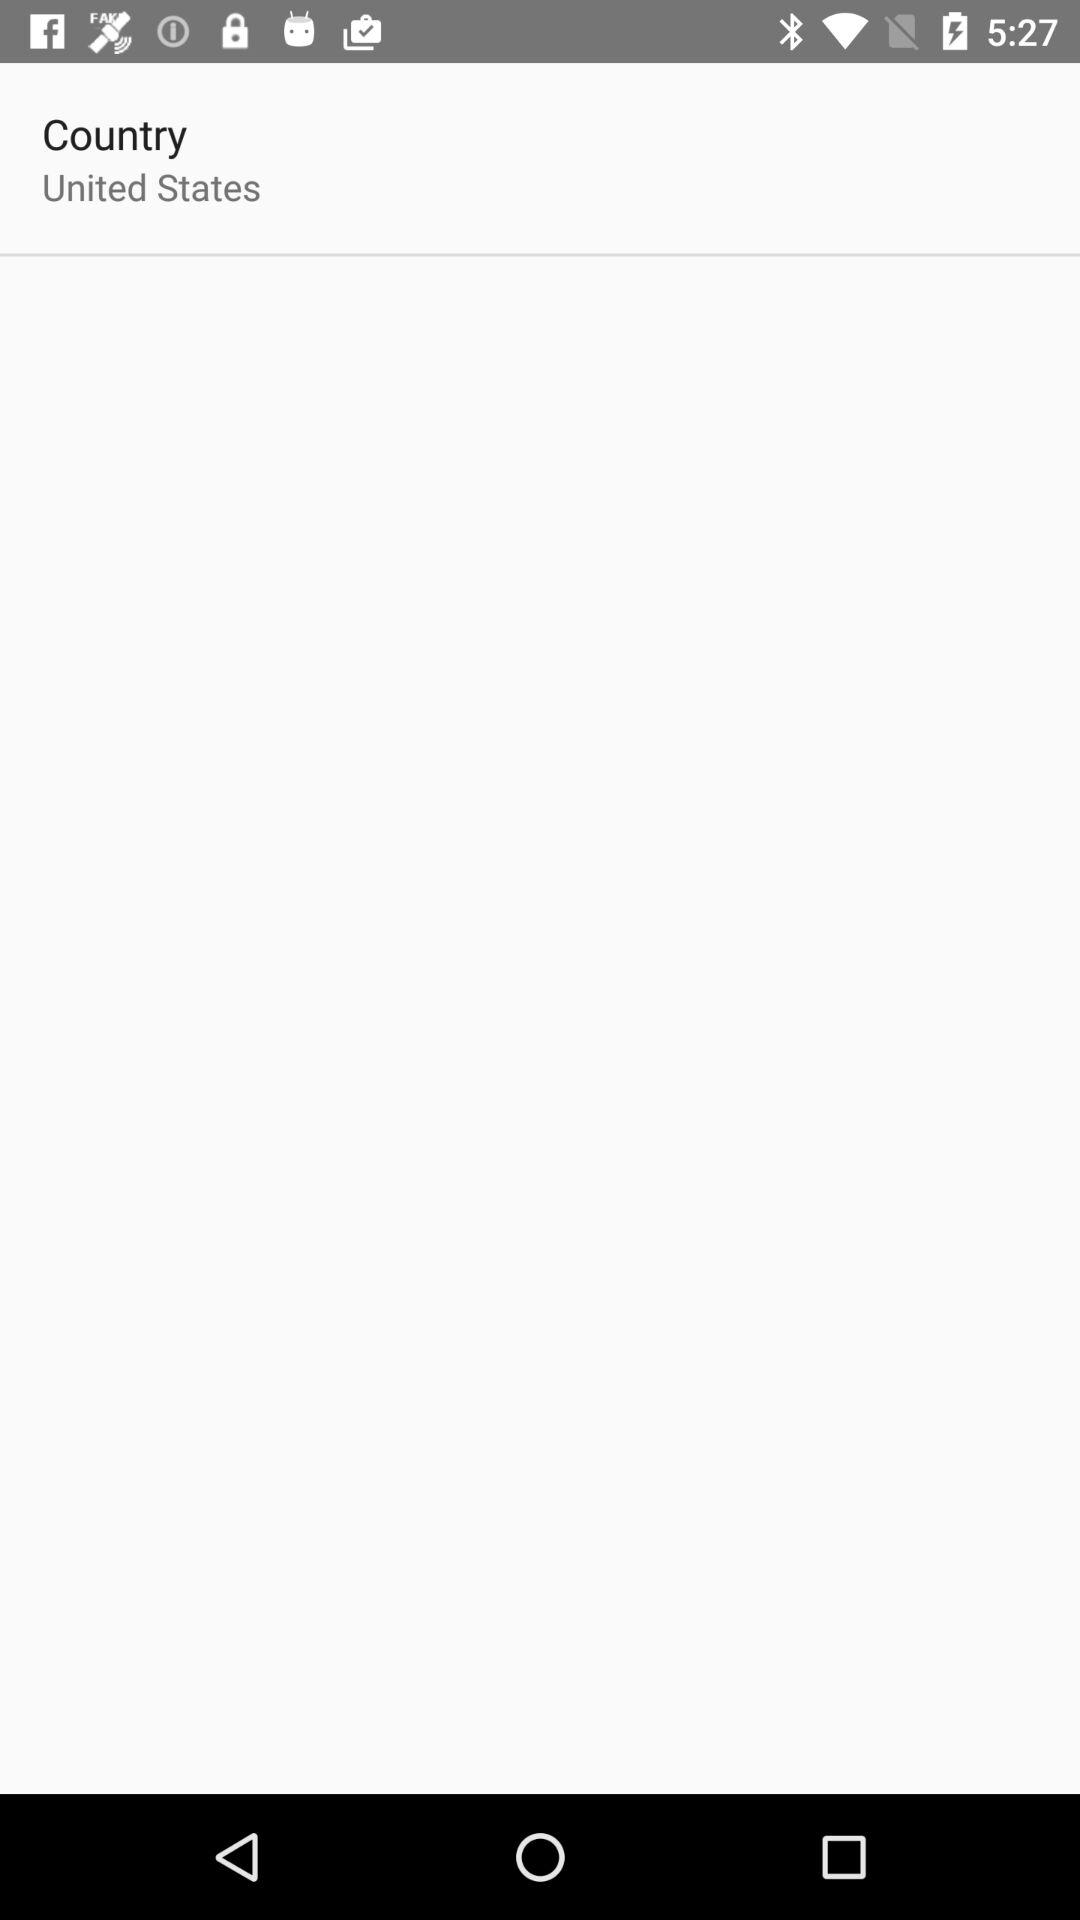What is the mentioned country? The mentioned country is the United States. 